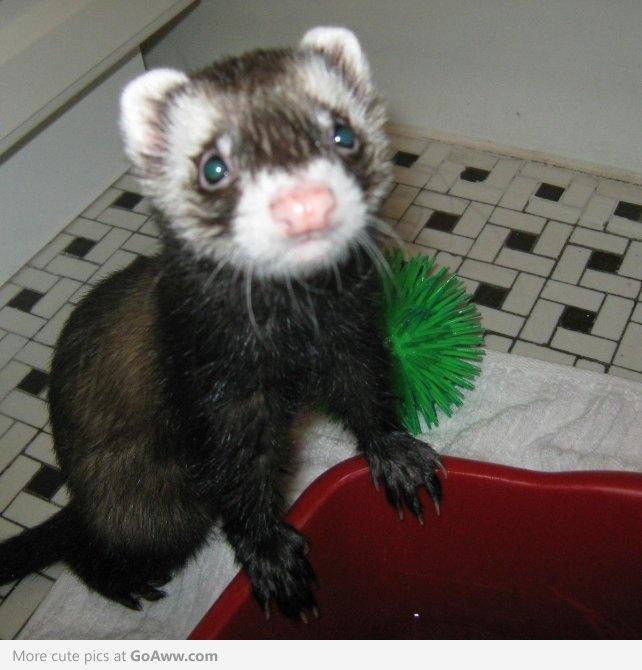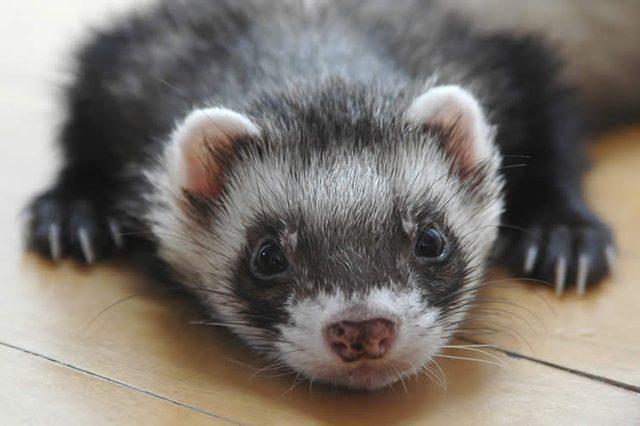The first image is the image on the left, the second image is the image on the right. Assess this claim about the two images: "The left image contains two ferrets.". Correct or not? Answer yes or no. No. The first image is the image on the left, the second image is the image on the right. Evaluate the accuracy of this statement regarding the images: "At least one ferret has its front paws draped over an edge, and multiple ferrets are peering forward.". Is it true? Answer yes or no. Yes. 